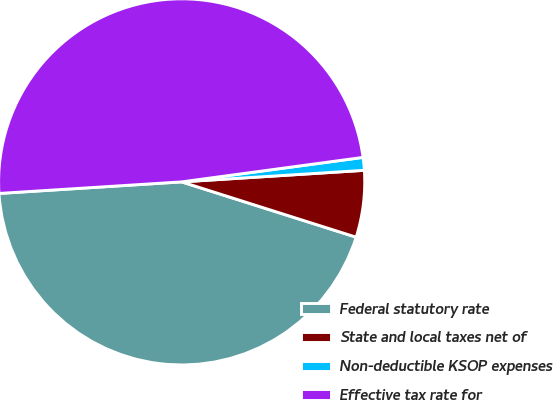Convert chart. <chart><loc_0><loc_0><loc_500><loc_500><pie_chart><fcel>Federal statutory rate<fcel>State and local taxes net of<fcel>Non-deductible KSOP expenses<fcel>Effective tax rate for<nl><fcel>44.11%<fcel>5.89%<fcel>1.13%<fcel>48.87%<nl></chart> 